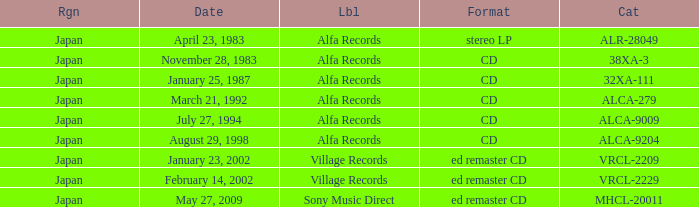Which date is in stereo lp format? April 23, 1983. 